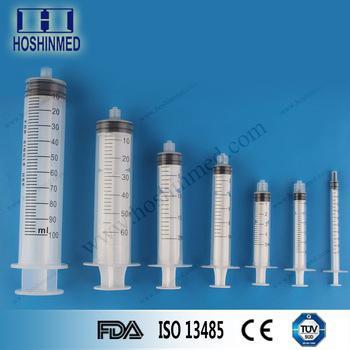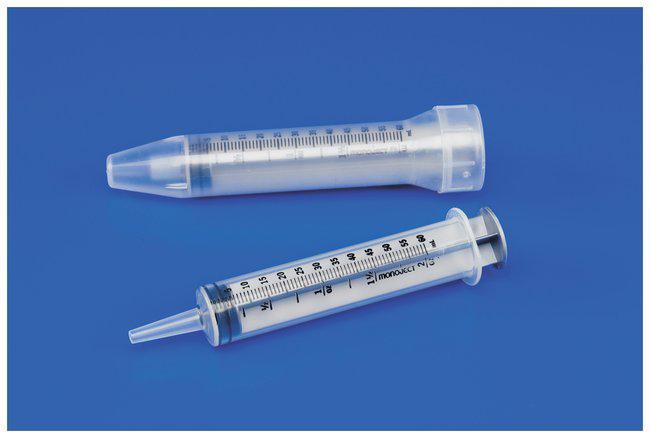The first image is the image on the left, the second image is the image on the right. For the images shown, is this caption "There are more than twelve syringes in total." true? Answer yes or no. No. The first image is the image on the left, the second image is the image on the right. Given the left and right images, does the statement "There are at least fourteen syringes with needle on them." hold true? Answer yes or no. No. 